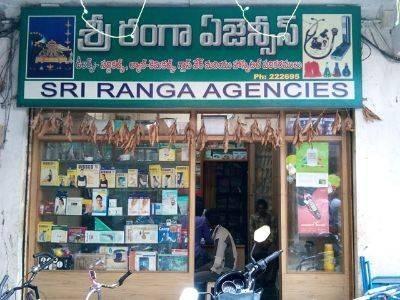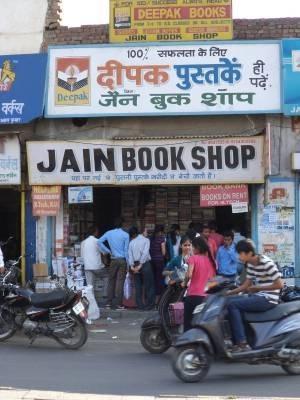The first image is the image on the left, the second image is the image on the right. Assess this claim about the two images: "There are people standing.". Correct or not? Answer yes or no. Yes. 